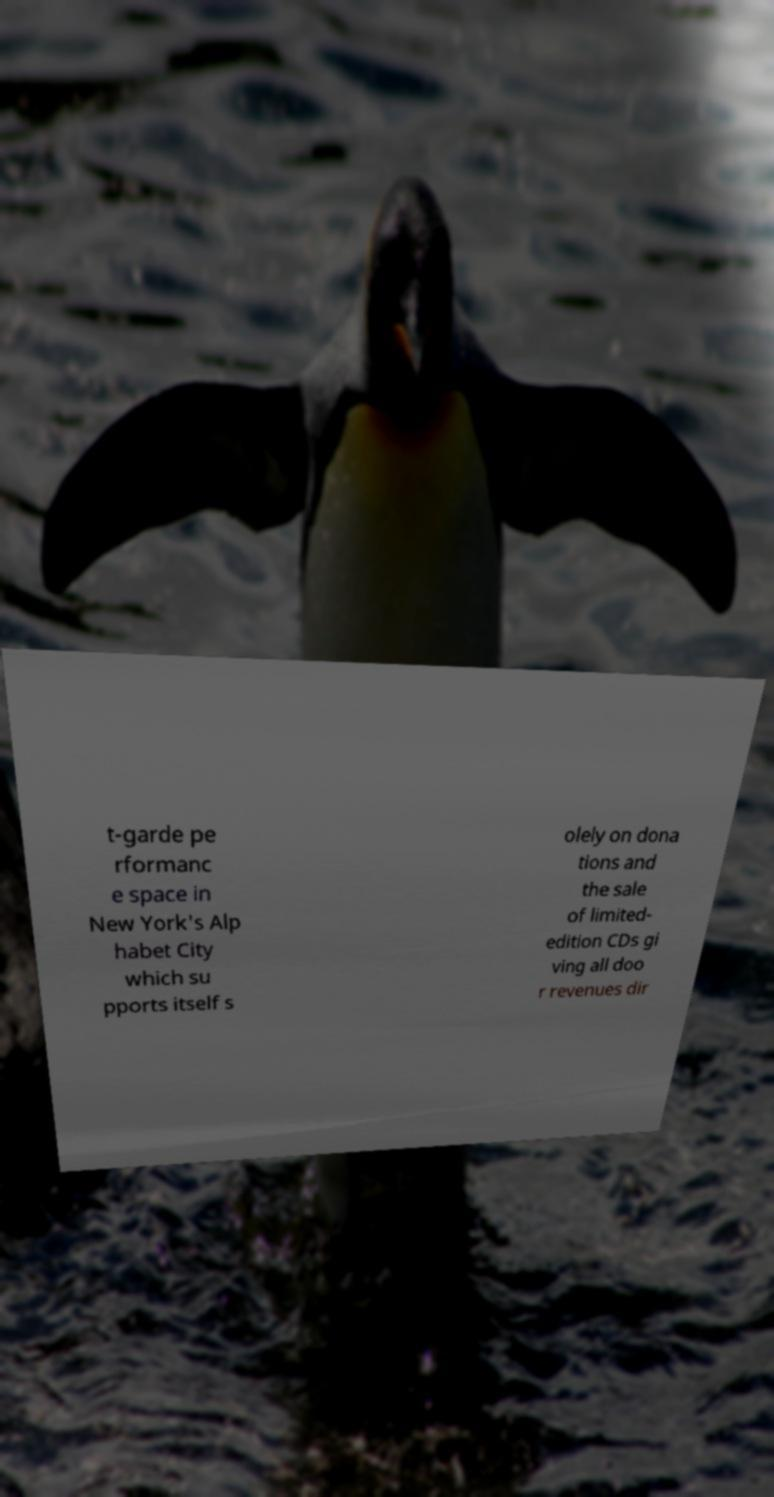Can you accurately transcribe the text from the provided image for me? t-garde pe rformanc e space in New York's Alp habet City which su pports itself s olely on dona tions and the sale of limited- edition CDs gi ving all doo r revenues dir 